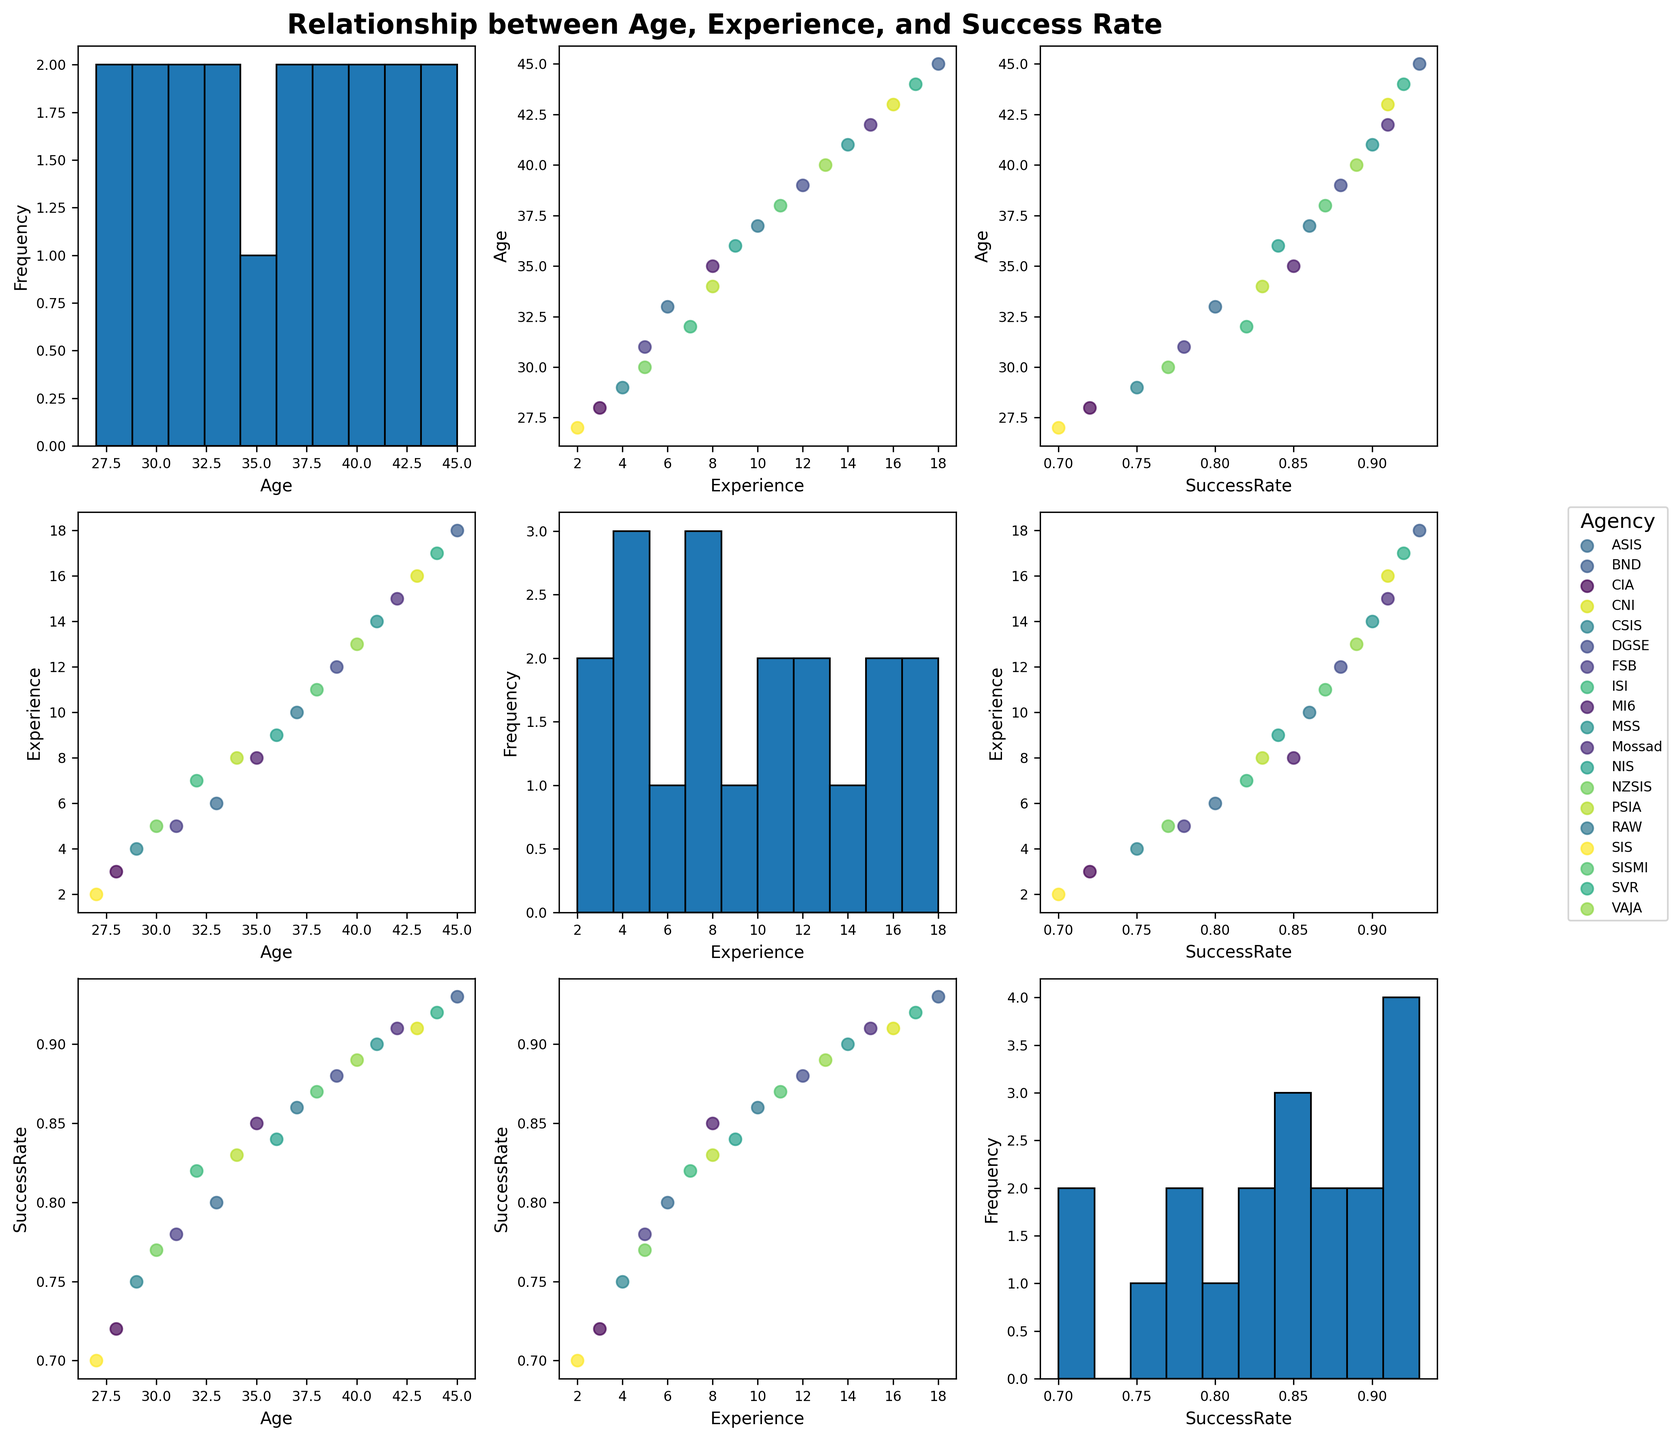What's the title of the figure? The title is prominent and located at the top of the figure. It states "Relationship between Age, Experience, and Success Rate."
Answer: Relationship between Age, Experience, and Success Rate How many unique intelligence agencies are represented by different colors? By observing the color legend on the right side of the figure, we can count the unique agencies listed.
Answer: 19 What is plotted on the scatterplots along the diagonal of the matrix? The diagonal of the scatterplot matrix usually represents histograms or density plots of each variable. Here, it shows the histogram for "Age," "Experience," and "Success Rate."
Answer: Histograms Which agency shows the highest success rate for its operatives, based on the scatterplot matrix? By examining the scatterplots, the BND (Federal Intelligence Service of Germany) has operatives with one of the highest success rates plotted near 0.93.
Answer: BND What is the median value of operatives' ages from the histogram? To find the median age, we look at the "Age" histogram plot and identify the middle value.
Answer: Around 37 years Are there more operatives with an experience level below or above 10 years? By looking at the histogram for "Experience," we can see the distribution of operatives' experience.
Answer: Below 10 years Which two agencies have the closest average success rates? By comparing the central tendencies of the success rates in the scatterplots, ISI (Inter-Services Intelligence) and PSIA (Public Security Intelligence Agency) have very close average success rates around 0.82 and 0.83, respectively.
Answer: ISI and PSIA What is the trend observed between age and mission success rates in the scatterplot? By examining the scatterplot of "Age" vs. "SuccessRate," there is a positive correlation where older operatives tend to have higher success rates.
Answer: Positive correlation Is there a visible correlation between years of experience and mission success rate? The scatterplot of "Experience" vs. "SuccessRate" displays a clear positive correlation, indicating that more experienced operatives tend to have higher mission success rates.
Answer: Positive correlation Which variable appears to have the most uniform distribution based on the histogram? Observing the histograms along the diagonal, the variable "Age" seems to have the most uniform distribution compared to "Experience" and "SuccessRate."
Answer: Age 